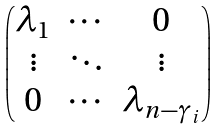<formula> <loc_0><loc_0><loc_500><loc_500>\begin{pmatrix} \lambda _ { 1 } & \cdots & 0 \\ \vdots & \ddots & \vdots \\ 0 & \cdots & \lambda _ { n - \gamma _ { i } } \end{pmatrix}</formula> 